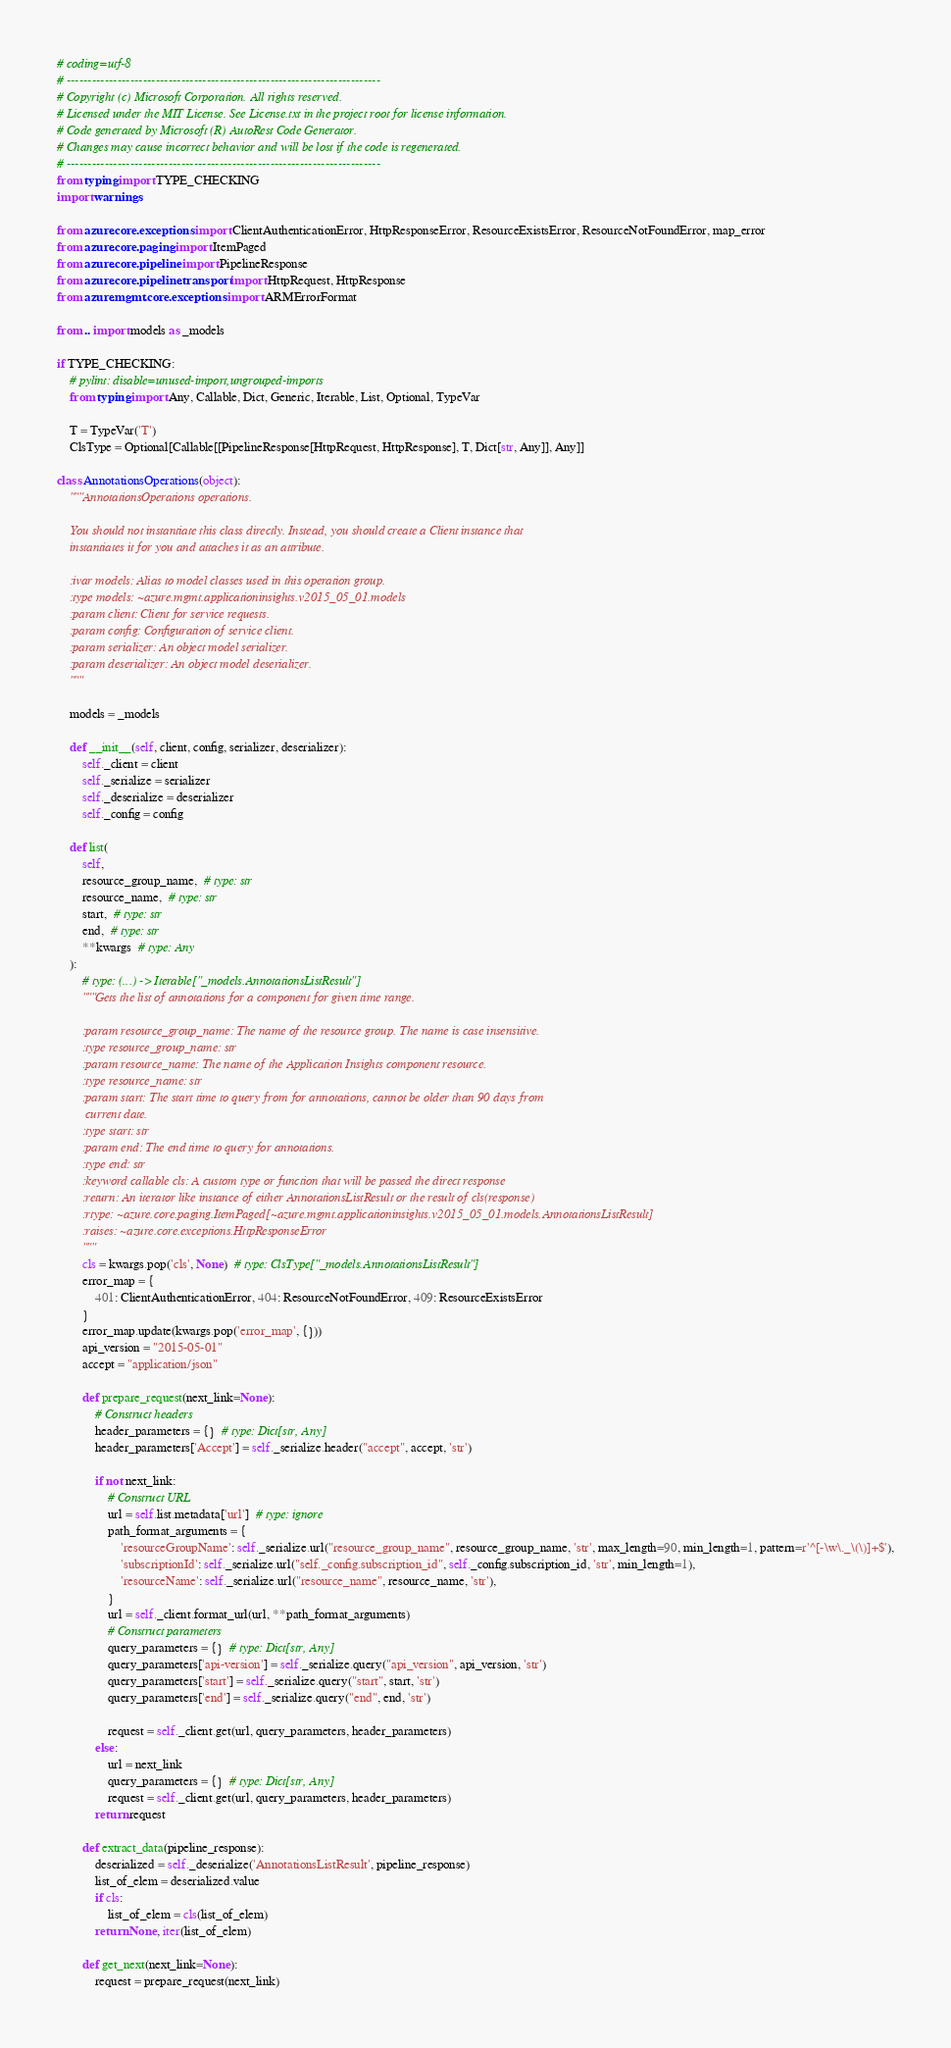<code> <loc_0><loc_0><loc_500><loc_500><_Python_># coding=utf-8
# --------------------------------------------------------------------------
# Copyright (c) Microsoft Corporation. All rights reserved.
# Licensed under the MIT License. See License.txt in the project root for license information.
# Code generated by Microsoft (R) AutoRest Code Generator.
# Changes may cause incorrect behavior and will be lost if the code is regenerated.
# --------------------------------------------------------------------------
from typing import TYPE_CHECKING
import warnings

from azure.core.exceptions import ClientAuthenticationError, HttpResponseError, ResourceExistsError, ResourceNotFoundError, map_error
from azure.core.paging import ItemPaged
from azure.core.pipeline import PipelineResponse
from azure.core.pipeline.transport import HttpRequest, HttpResponse
from azure.mgmt.core.exceptions import ARMErrorFormat

from .. import models as _models

if TYPE_CHECKING:
    # pylint: disable=unused-import,ungrouped-imports
    from typing import Any, Callable, Dict, Generic, Iterable, List, Optional, TypeVar

    T = TypeVar('T')
    ClsType = Optional[Callable[[PipelineResponse[HttpRequest, HttpResponse], T, Dict[str, Any]], Any]]

class AnnotationsOperations(object):
    """AnnotationsOperations operations.

    You should not instantiate this class directly. Instead, you should create a Client instance that
    instantiates it for you and attaches it as an attribute.

    :ivar models: Alias to model classes used in this operation group.
    :type models: ~azure.mgmt.applicationinsights.v2015_05_01.models
    :param client: Client for service requests.
    :param config: Configuration of service client.
    :param serializer: An object model serializer.
    :param deserializer: An object model deserializer.
    """

    models = _models

    def __init__(self, client, config, serializer, deserializer):
        self._client = client
        self._serialize = serializer
        self._deserialize = deserializer
        self._config = config

    def list(
        self,
        resource_group_name,  # type: str
        resource_name,  # type: str
        start,  # type: str
        end,  # type: str
        **kwargs  # type: Any
    ):
        # type: (...) -> Iterable["_models.AnnotationsListResult"]
        """Gets the list of annotations for a component for given time range.

        :param resource_group_name: The name of the resource group. The name is case insensitive.
        :type resource_group_name: str
        :param resource_name: The name of the Application Insights component resource.
        :type resource_name: str
        :param start: The start time to query from for annotations, cannot be older than 90 days from
         current date.
        :type start: str
        :param end: The end time to query for annotations.
        :type end: str
        :keyword callable cls: A custom type or function that will be passed the direct response
        :return: An iterator like instance of either AnnotationsListResult or the result of cls(response)
        :rtype: ~azure.core.paging.ItemPaged[~azure.mgmt.applicationinsights.v2015_05_01.models.AnnotationsListResult]
        :raises: ~azure.core.exceptions.HttpResponseError
        """
        cls = kwargs.pop('cls', None)  # type: ClsType["_models.AnnotationsListResult"]
        error_map = {
            401: ClientAuthenticationError, 404: ResourceNotFoundError, 409: ResourceExistsError
        }
        error_map.update(kwargs.pop('error_map', {}))
        api_version = "2015-05-01"
        accept = "application/json"

        def prepare_request(next_link=None):
            # Construct headers
            header_parameters = {}  # type: Dict[str, Any]
            header_parameters['Accept'] = self._serialize.header("accept", accept, 'str')

            if not next_link:
                # Construct URL
                url = self.list.metadata['url']  # type: ignore
                path_format_arguments = {
                    'resourceGroupName': self._serialize.url("resource_group_name", resource_group_name, 'str', max_length=90, min_length=1, pattern=r'^[-\w\._\(\)]+$'),
                    'subscriptionId': self._serialize.url("self._config.subscription_id", self._config.subscription_id, 'str', min_length=1),
                    'resourceName': self._serialize.url("resource_name", resource_name, 'str'),
                }
                url = self._client.format_url(url, **path_format_arguments)
                # Construct parameters
                query_parameters = {}  # type: Dict[str, Any]
                query_parameters['api-version'] = self._serialize.query("api_version", api_version, 'str')
                query_parameters['start'] = self._serialize.query("start", start, 'str')
                query_parameters['end'] = self._serialize.query("end", end, 'str')

                request = self._client.get(url, query_parameters, header_parameters)
            else:
                url = next_link
                query_parameters = {}  # type: Dict[str, Any]
                request = self._client.get(url, query_parameters, header_parameters)
            return request

        def extract_data(pipeline_response):
            deserialized = self._deserialize('AnnotationsListResult', pipeline_response)
            list_of_elem = deserialized.value
            if cls:
                list_of_elem = cls(list_of_elem)
            return None, iter(list_of_elem)

        def get_next(next_link=None):
            request = prepare_request(next_link)
</code> 